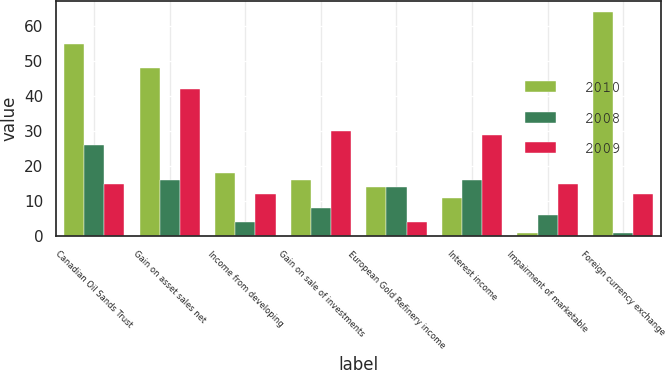Convert chart. <chart><loc_0><loc_0><loc_500><loc_500><stacked_bar_chart><ecel><fcel>Canadian Oil Sands Trust<fcel>Gain on asset sales net<fcel>Income from developing<fcel>Gain on sale of investments<fcel>European Gold Refinery income<fcel>Interest income<fcel>Impairment of marketable<fcel>Foreign currency exchange<nl><fcel>2010<fcel>55<fcel>48<fcel>18<fcel>16<fcel>14<fcel>11<fcel>1<fcel>64<nl><fcel>2008<fcel>26<fcel>16<fcel>4<fcel>8<fcel>14<fcel>16<fcel>6<fcel>1<nl><fcel>2009<fcel>15<fcel>42<fcel>12<fcel>30<fcel>4<fcel>29<fcel>15<fcel>12<nl></chart> 